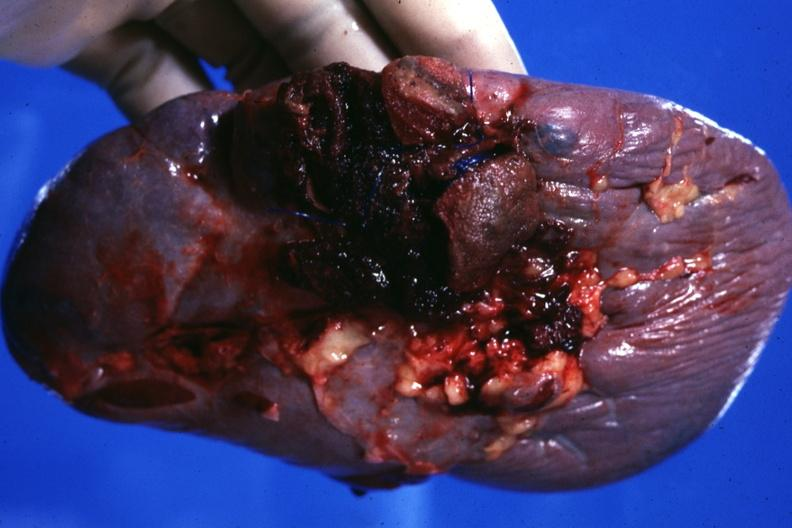what is present?
Answer the question using a single word or phrase. Spleen 